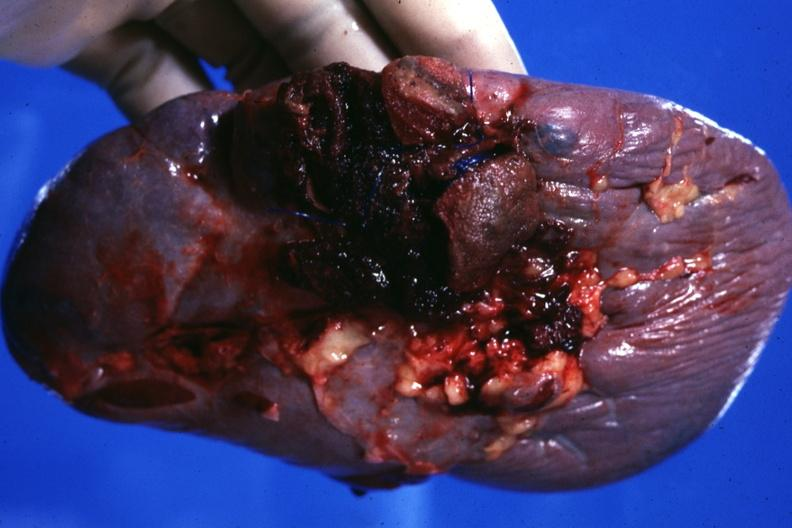what is present?
Answer the question using a single word or phrase. Spleen 